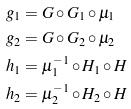Convert formula to latex. <formula><loc_0><loc_0><loc_500><loc_500>g _ { 1 } & = G \circ G _ { 1 } \circ \mu _ { 1 } \\ g _ { 2 } & = G \circ G _ { 2 } \circ \mu _ { 2 } \\ h _ { 1 } & = \mu _ { 1 } ^ { - 1 } \circ H _ { 1 } \circ H \\ h _ { 2 } & = \mu _ { 2 } ^ { - 1 } \circ H _ { 2 } \circ H</formula> 